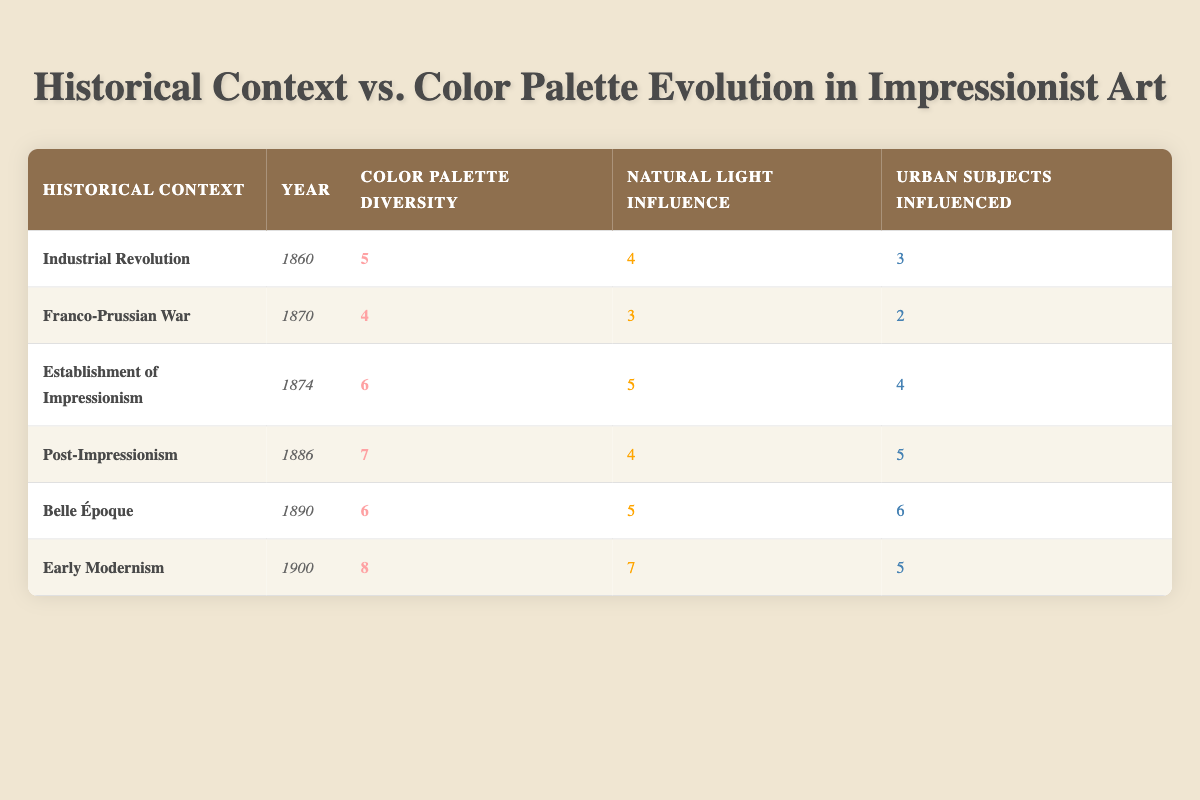What year was the establishment of Impressionism? According to the table, the establishment of Impressionism occurred in the year 1874.
Answer: 1874 What is the color palette diversity for the Early Modernism context? The table indicates that the color palette diversity for the Early Modernism context is 8.
Answer: 8 How many historical contexts had a natural light influence of 5 or more? By examining the table, the contexts with a natural light influence of 5 or more are: Establishment of Impressionism (5), Belle Époque (5), and Early Modernism (7). There are a total of 3 contexts meeting this criterion.
Answer: 3 What is the difference between the color palette diversity of Post-Impressionism and Belle Époque? The color palette diversity for Post-Impressionism is 7 and for Belle Époque is 6. Calculating the difference gives us 7 - 6 = 1.
Answer: 1 Is there a historical context where urban subjects influenced is equal to 6? Yes, the table shows that for the Belle Époque context, the urban subjects influenced is 6.
Answer: Yes What is the average natural light influence across all historical contexts? To find the average, we sum the natural light influence values (4 + 3 + 5 + 4 + 5 + 7 = 28) and divide by the number of contexts (6). Thus, 28 / 6 = 4.67, rounding to two decimal places gives 4.67.
Answer: 4.67 In which historical context did the color palette diversity peak? The highest value for color palette diversity in the table is 8, found in the Early Modernism context.
Answer: Early Modernism What was the natural light influence during the Franco-Prussian War? The table shows that the natural light influence during the Franco-Prussian War is 3.
Answer: 3 How does the urban subjects influenced score of the Industrial Revolution compare to that of the Early Modernism? For the Industrial Revolution, the urban subjects influenced score is 3, while for Early Modernism it is 5. Thus, the comparison shows that Early Modernism has a higher score by 2.
Answer: 2 